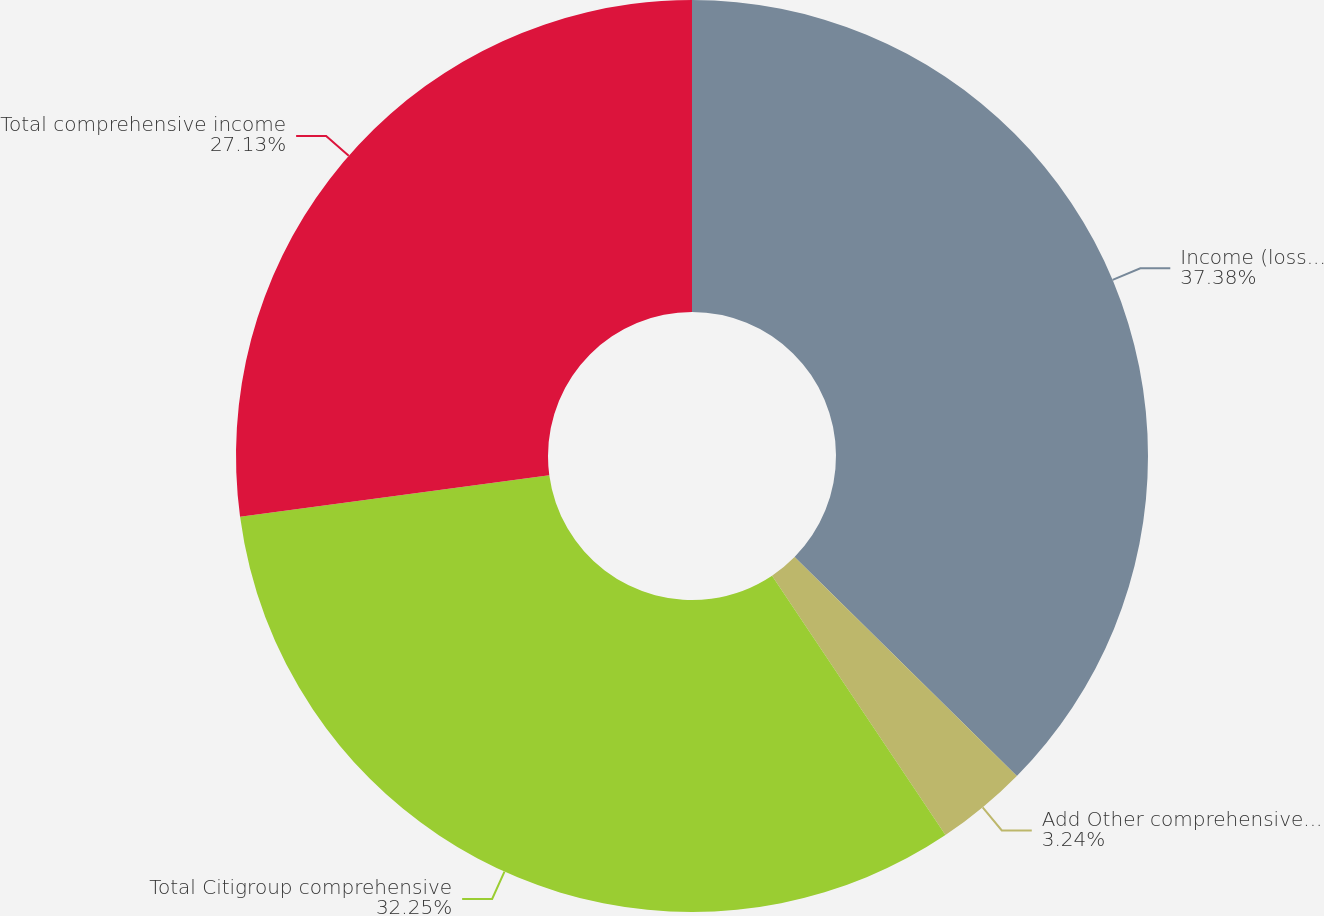<chart> <loc_0><loc_0><loc_500><loc_500><pie_chart><fcel>Income (loss) from continuing<fcel>Add Other comprehensive income<fcel>Total Citigroup comprehensive<fcel>Total comprehensive income<nl><fcel>37.38%<fcel>3.24%<fcel>32.25%<fcel>27.13%<nl></chart> 